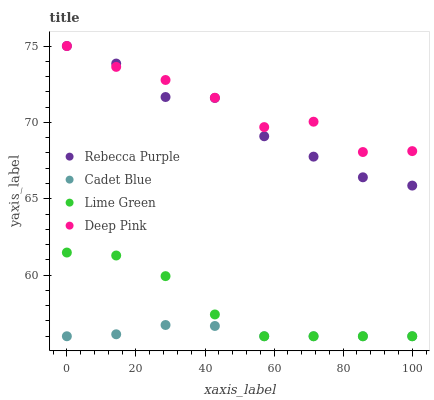Does Cadet Blue have the minimum area under the curve?
Answer yes or no. Yes. Does Deep Pink have the maximum area under the curve?
Answer yes or no. Yes. Does Lime Green have the minimum area under the curve?
Answer yes or no. No. Does Lime Green have the maximum area under the curve?
Answer yes or no. No. Is Cadet Blue the smoothest?
Answer yes or no. Yes. Is Deep Pink the roughest?
Answer yes or no. Yes. Is Lime Green the smoothest?
Answer yes or no. No. Is Lime Green the roughest?
Answer yes or no. No. Does Cadet Blue have the lowest value?
Answer yes or no. Yes. Does Rebecca Purple have the lowest value?
Answer yes or no. No. Does Deep Pink have the highest value?
Answer yes or no. Yes. Does Lime Green have the highest value?
Answer yes or no. No. Is Cadet Blue less than Rebecca Purple?
Answer yes or no. Yes. Is Deep Pink greater than Cadet Blue?
Answer yes or no. Yes. Does Lime Green intersect Cadet Blue?
Answer yes or no. Yes. Is Lime Green less than Cadet Blue?
Answer yes or no. No. Is Lime Green greater than Cadet Blue?
Answer yes or no. No. Does Cadet Blue intersect Rebecca Purple?
Answer yes or no. No. 